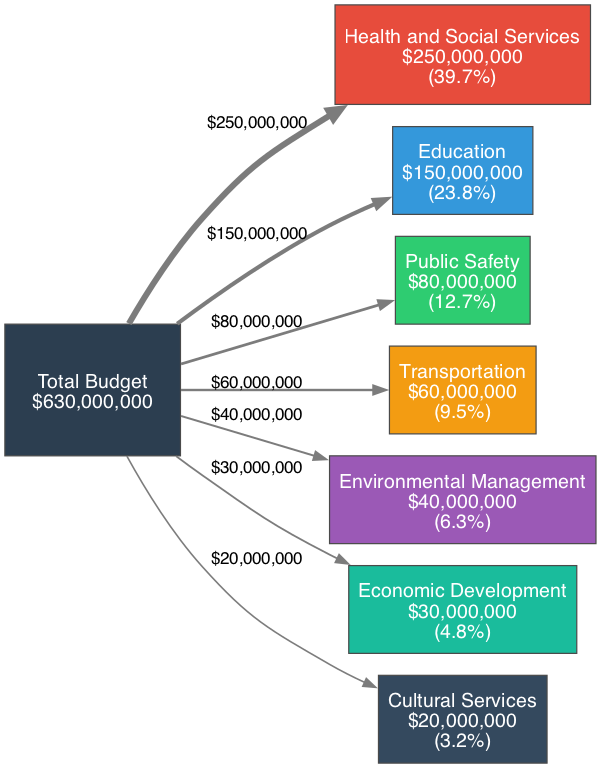What is the total budget for all sectors in Yukon for the fiscal year 2022-2023? The diagram indicates that the total budget is represented in the "Total" node, which states that the total budget is $1,000,000,000.
Answer: $1,000,000,000 Which sector has the highest budget allocation? By examining each sector's budget listed in the nodes, it is clear that the "Health and Social Services" sector has the highest budget at $250,000,000.
Answer: Health and Social Services How much budget is allocated to the Education sector? Looking directly at the node corresponding to the Education sector, the label shows that it has a budget of $150,000,000.
Answer: $150,000,000 What percentage of the total budget is allocated to Public Safety? To find this, I need to check the budget for Public Safety, which is $80,000,000, and calculate its percentage compared to the total budget of $1,000,000,000. The calculation is (80,000,000 / 1,000,000,000) * 100, which equals 8.0%.
Answer: 8.0% Which sector has the lowest budget allocation? By checking all sectors, the "Cultural Services" sector has the lowest budget allocation, which is $20,000,000.
Answer: Cultural Services What is the total budget for Environmental Management and Economic Development combined? The budgets for Environmental Management ($40,000,000) and Economic Development ($30,000,000) can be summed up: 40,000,000 + 30,000,000 equals $70,000,000.
Answer: $70,000,000 How does the budget allocation for Transportation compare to that of Education? My analysis of the diagram shows that Transportation has a budget of $60,000,000 while Education has $150,000,000. Therefore, Education’s budget is significantly larger than Transportation's by $90,000,000.
Answer: $90,000,000 If the budget for Environmental Management increased by 10%, what would be its new total? The original budget for Environmental Management is $40,000,000. A 10% increase would mean adding $4,000,000 to the original budget, making the new total $44,000,000 (40,000,000 + 4,000,000).
Answer: $44,000,000 How many sectors are represented in the diagram? The diagram displays a total of seven different sectors, as indicated by the nodes representing each one.
Answer: 7 